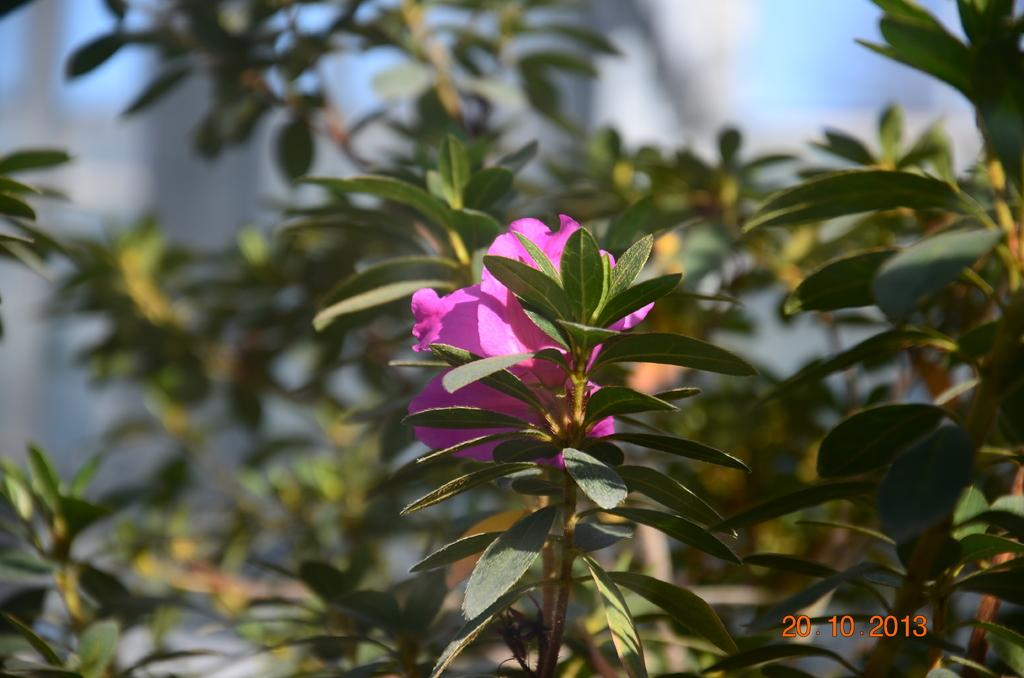What can be seen in the foreground of the picture? There are flowers and plants in the foreground of the picture. How would you describe the background of the image? The background of the image is blurred. Are there any plants visible in the background of the image? Yes, there are plants visible in the background of the image. What is the weather like in the image? The sky is sunny, indicating a clear and bright day. What type of arithmetic problem is being solved by the fish in the image? There are no fish present in the image, so no arithmetic problem can be solved by them. 